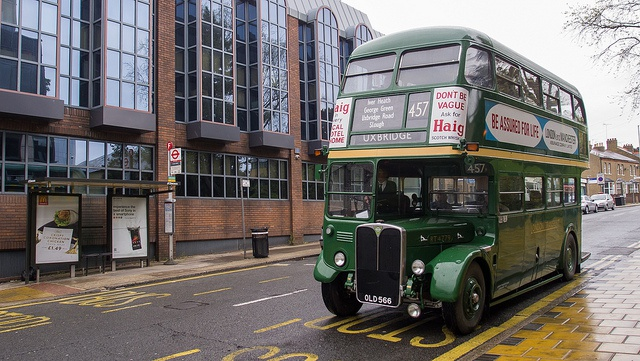Describe the objects in this image and their specific colors. I can see bus in lightpink, black, darkgray, gray, and darkgreen tones, people in lightpink, black, and gray tones, car in lightpink, lightgray, darkgray, and gray tones, bench in lightpink, black, and gray tones, and people in lightpink, black, and gray tones in this image. 